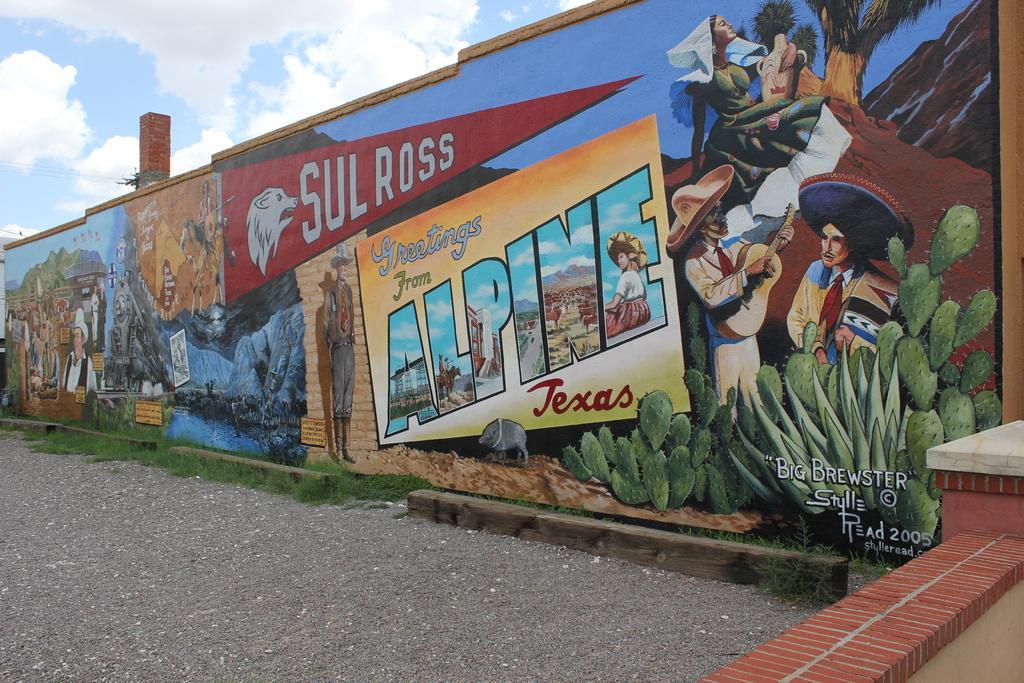Could you give a brief overview of what you see in this image? In this image, we can see a wall which is painted and also some text is written on it and at the end of the wall, we can see some small amount of grass and there is also a road and the sky is blue in color and it is almost cloudy. 